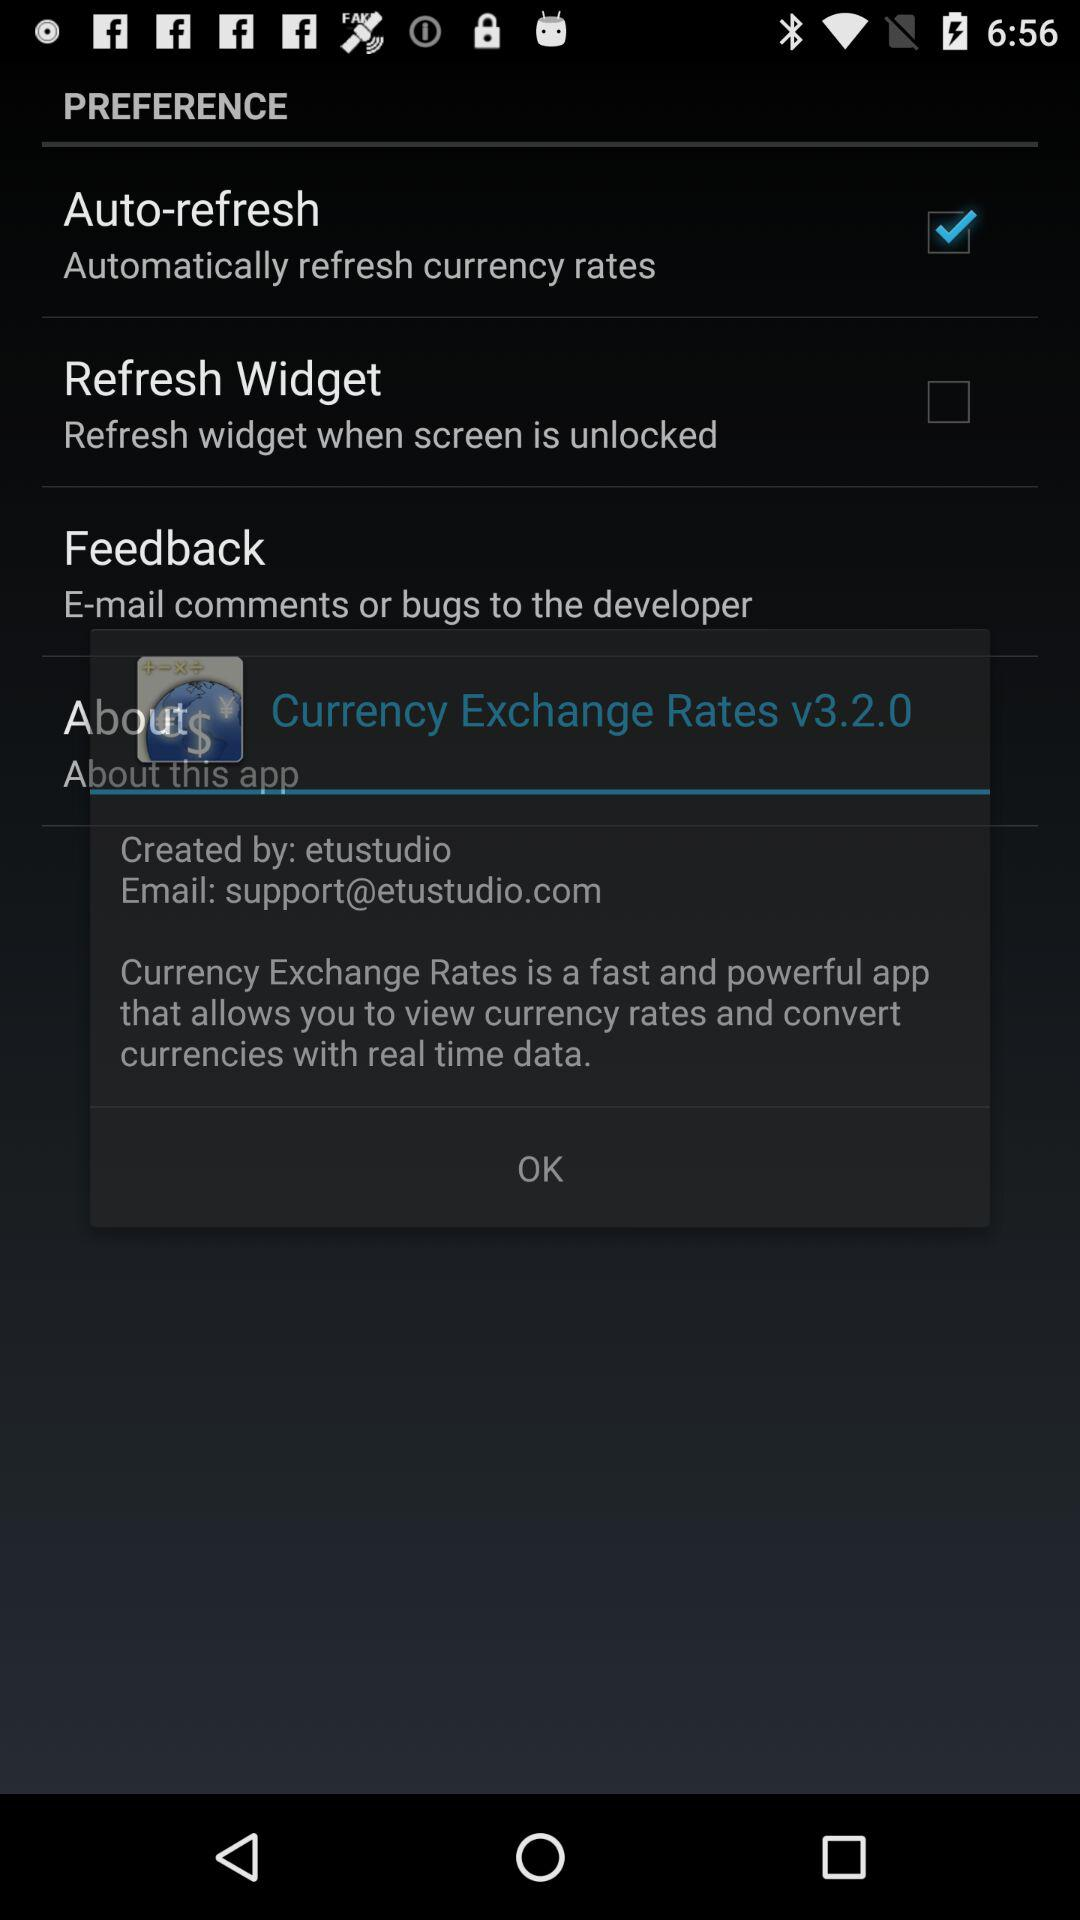Which date is the graph given for? The graph is given for January 30. 